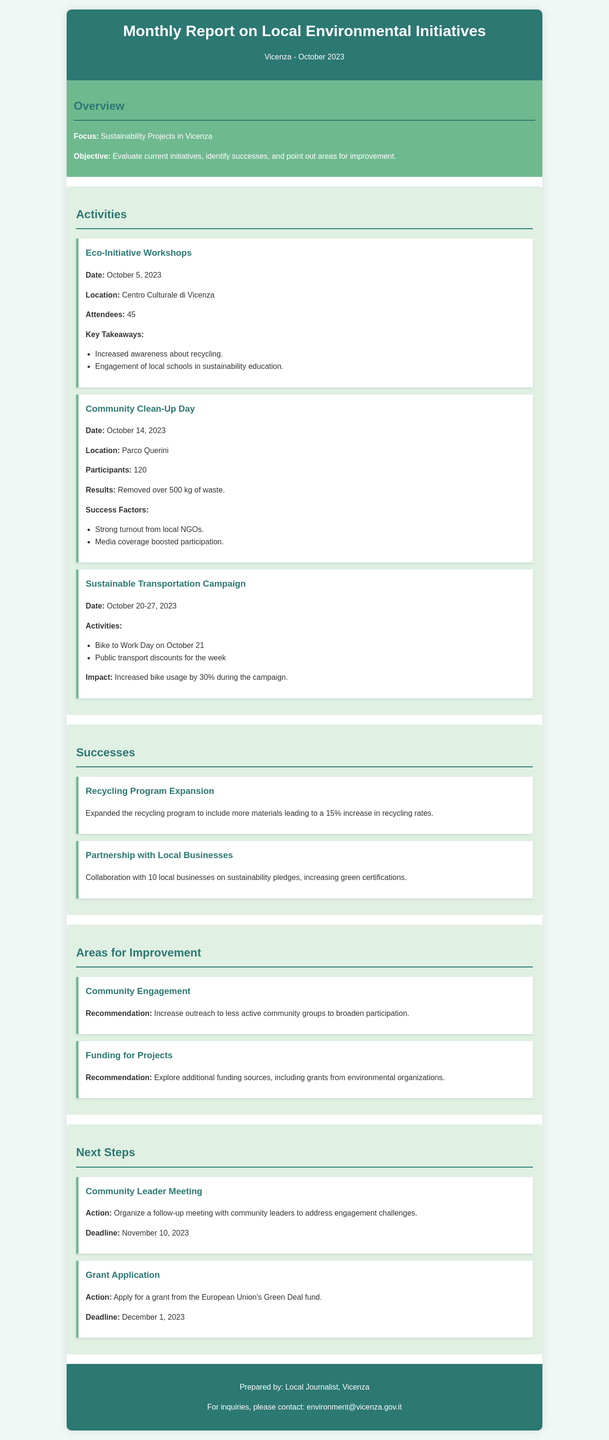What is the date of the Eco-Initiative Workshops? The Eco-Initiative Workshops took place on October 5, 2023.
Answer: October 5, 2023 How many participants were involved in the Community Clean-Up Day? The Community Clean-Up Day had 120 participants.
Answer: 120 What was the outcome of the Sustainable Transportation Campaign? The campaign resulted in a 30% increase in bike usage.
Answer: 30% What was one of the successes related to local businesses? The success involved collaboration with 10 local businesses on sustainability pledges.
Answer: 10 local businesses What is a recommended action for improving community engagement? It is recommended to increase outreach to less active community groups.
Answer: Increase outreach What is the deadline for the grant application action? The deadline for the grant application is December 1, 2023.
Answer: December 1, 2023 Where was the Community Clean-Up Day held? The Community Clean-Up Day took place at Parco Querini.
Answer: Parco Querini What material recycling rates increased by 15%? The recycling program expansion led to a 15% increase in recycling rates.
Answer: 15% What is the planned date for the Community Leader Meeting? The Community Leader Meeting is planned for November 10, 2023.
Answer: November 10, 2023 